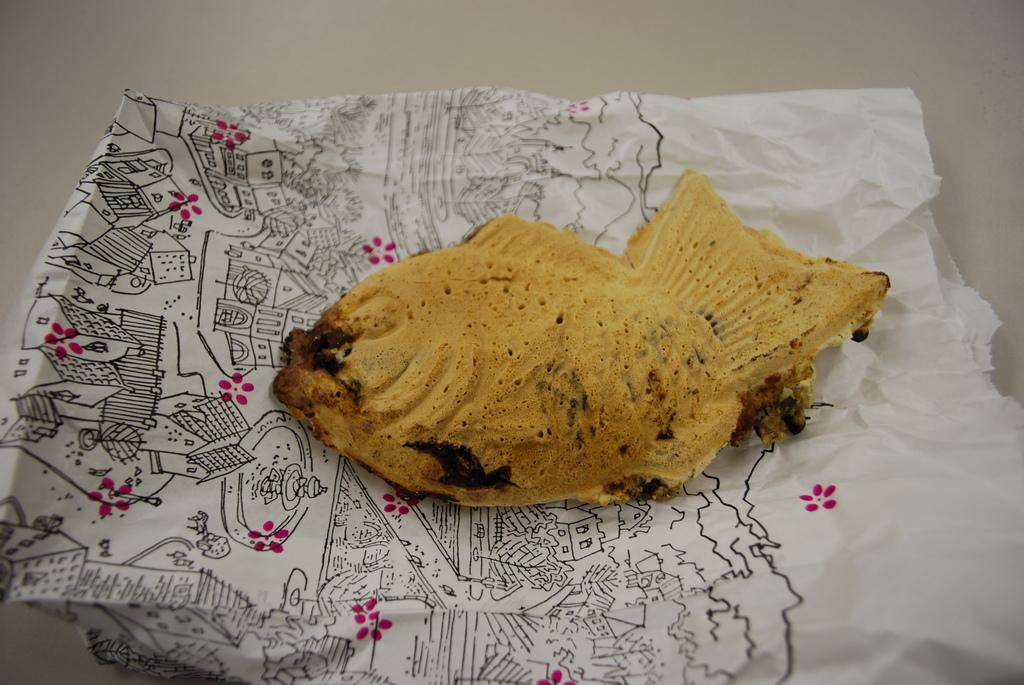What type of food is visible in the image? There is fried fish in the image. How is the fried fish presented? The fried fish is placed on a paper cover. What piece of furniture is present in the image? There is a table in the image. What type of lamp is visible on the table in the image? There is no lamp present in the image; only fried fish, a paper cover, and a table are visible. 